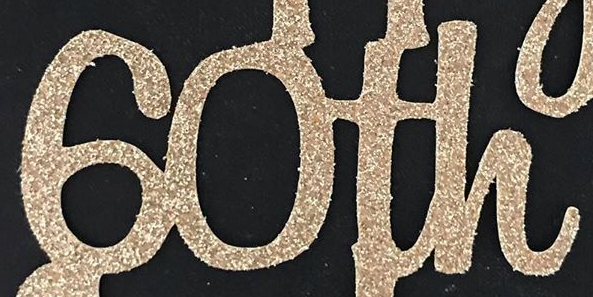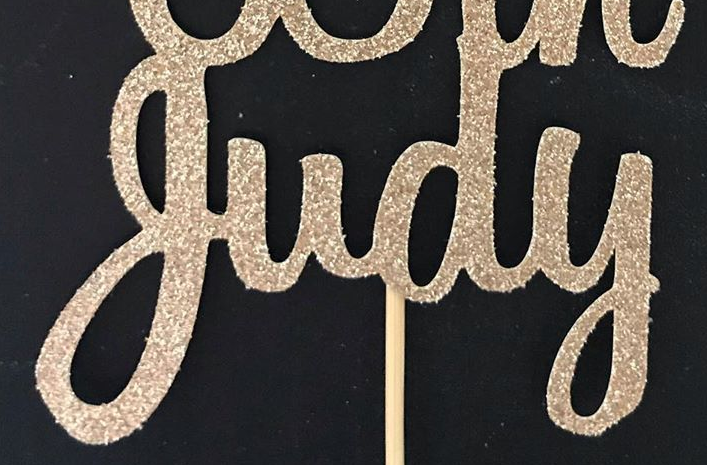What words can you see in these images in sequence, separated by a semicolon? 60th; judy 